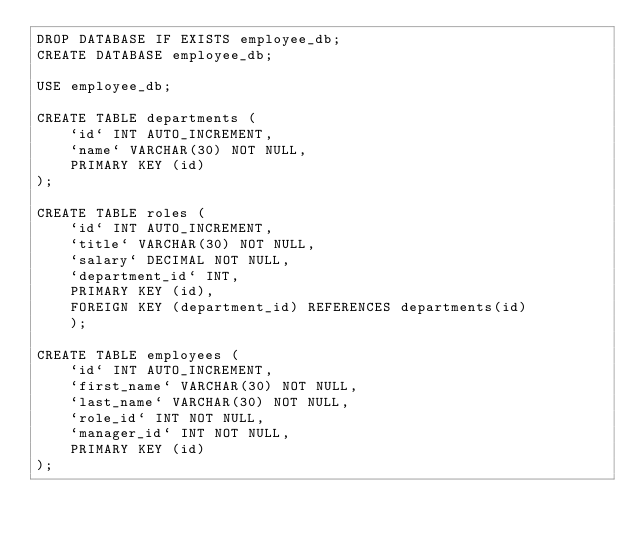<code> <loc_0><loc_0><loc_500><loc_500><_SQL_>DROP DATABASE IF EXISTS employee_db;
CREATE DATABASE employee_db;

USE employee_db;

CREATE TABLE departments (
    `id` INT AUTO_INCREMENT,
    `name` VARCHAR(30) NOT NULL,
    PRIMARY KEY (id)
);

CREATE TABLE roles (
    `id` INT AUTO_INCREMENT,
    `title` VARCHAR(30) NOT NULL,
    `salary` DECIMAL NOT NULL,
    `department_id` INT,
    PRIMARY KEY (id),
    FOREIGN KEY (department_id) REFERENCES departments(id)
    );

CREATE TABLE employees (
    `id` INT AUTO_INCREMENT,
    `first_name` VARCHAR(30) NOT NULL,
    `last_name` VARCHAR(30) NOT NULL,
    `role_id` INT NOT NULL,
    `manager_id` INT NOT NULL,
    PRIMARY KEY (id)
);



</code> 